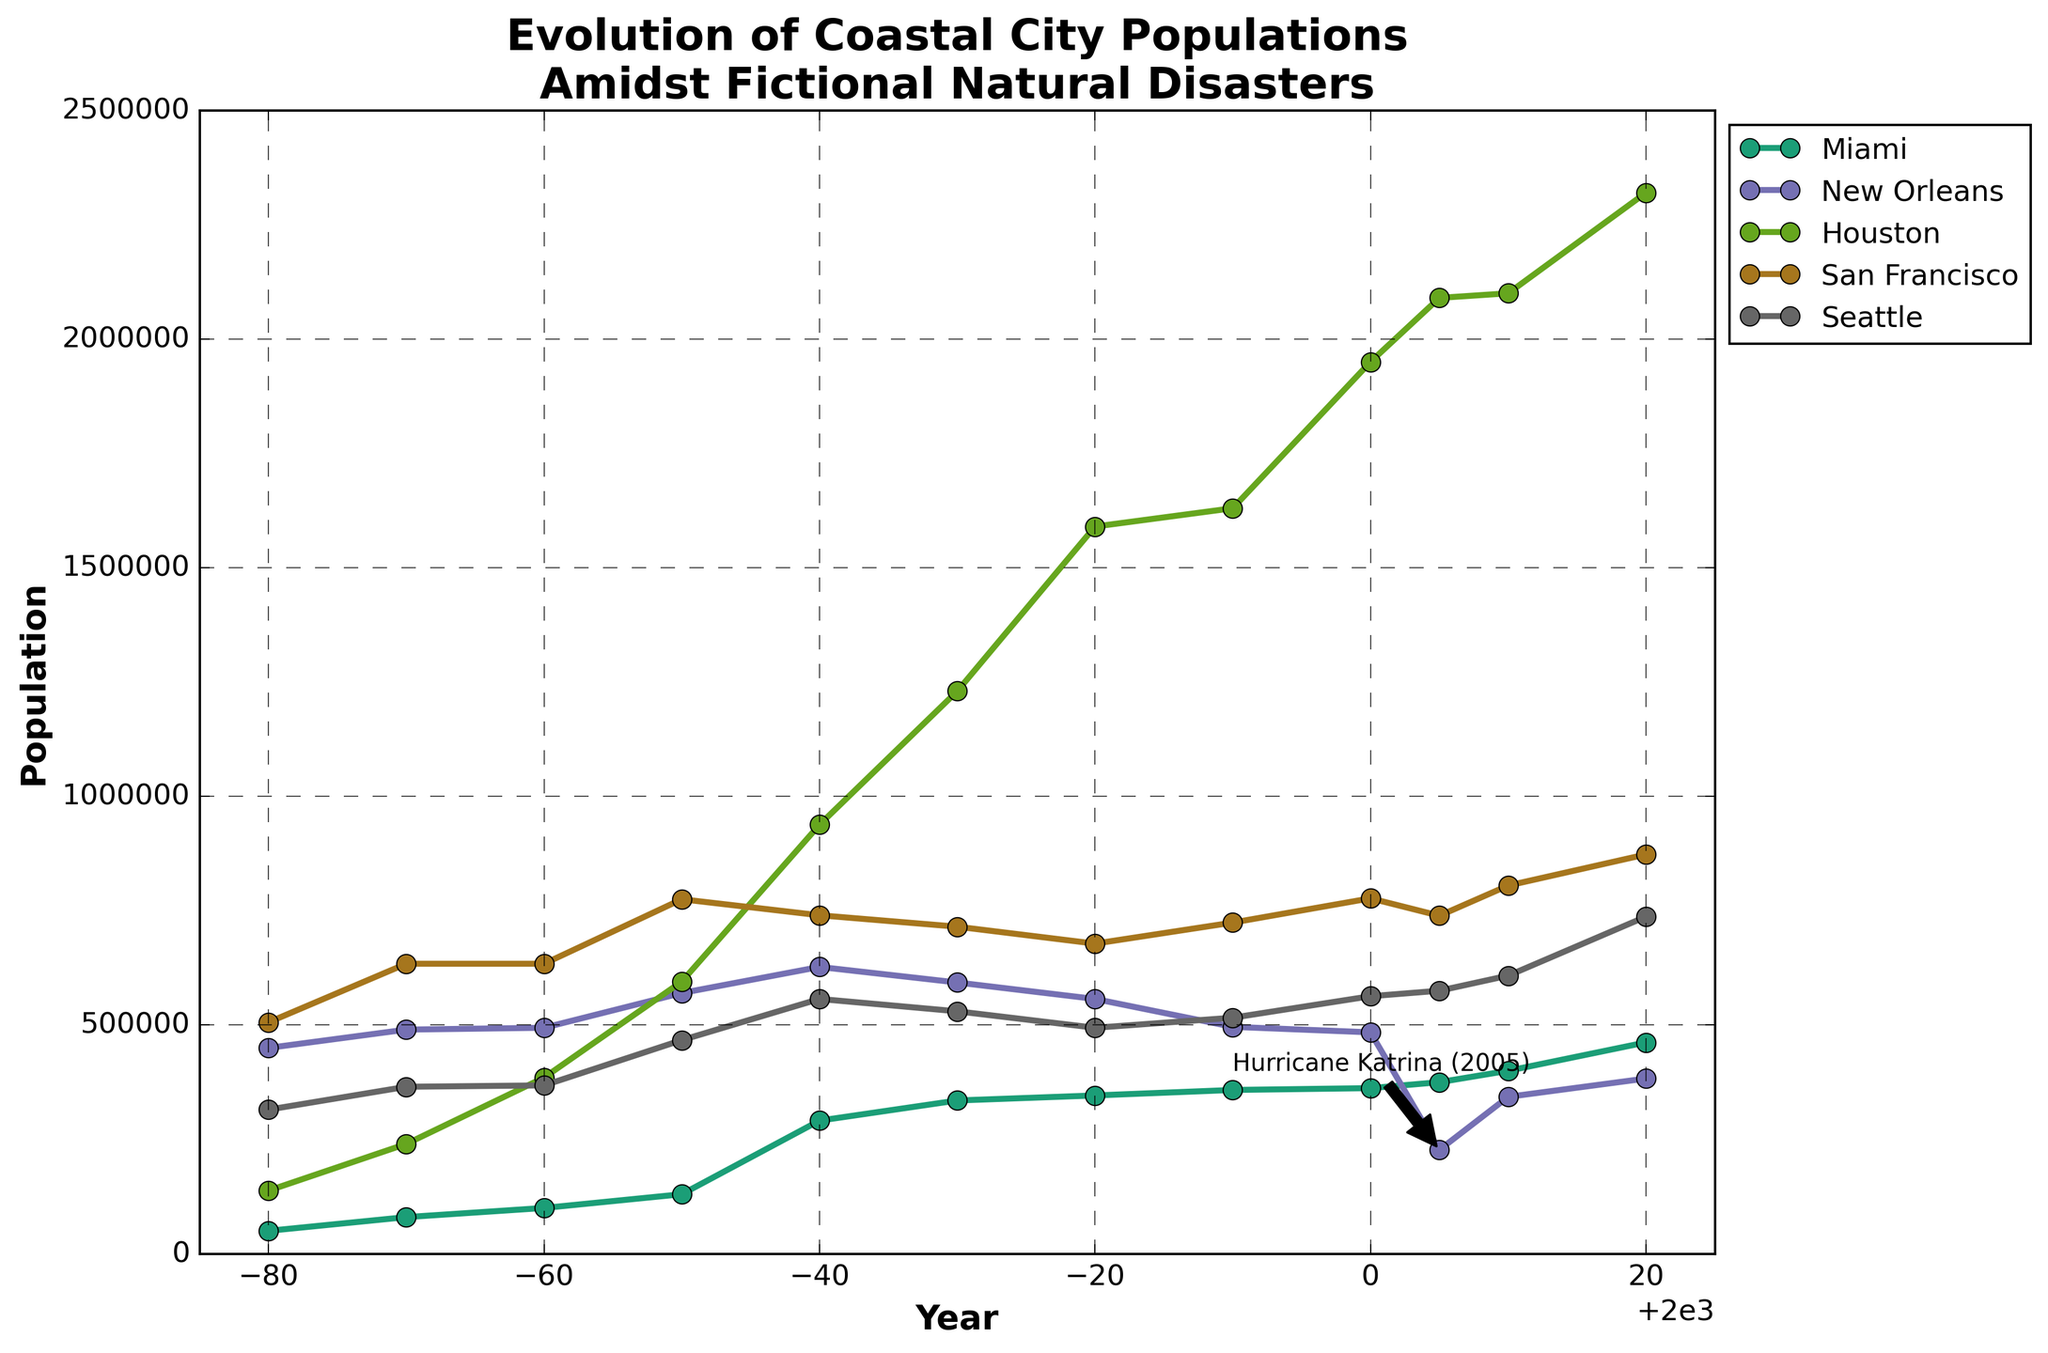What's the title of the figure? The title is typically located at the top of a figure or graph. In this case, it is clearly written above the plot.
Answer: Evolution of Coastal City Populations Amidst Fictional Natural Disasters What are the x-axis and y-axis labels? The x-axis label is usually at the bottom of the graph and the y-axis label is typically at the left side of the plot. Here, they are marked clearly.
Answer: Year, Population What year shows the largest population drop for New Orleans, and what was the population before and after the drop? From the plotted data, the year with the significant population drop is around 2005. Before the drop, the population was around 484,000, and after, it was about 227,000.
Answer: 2005, 484,000, 227,000 Which city had the highest population in 2020? The highest population in 2020 can be identified by looking for the tallest point on the y-axis for that year. Houston's population stands out.
Answer: Houston Between which years did Miami show the most significant population growth, and what were the respective populations? Miami shows the most obvious growth between 1950 and 1960, going from 130,000 to 291,000.
Answer: 1950-1960, 130,000, 291,000 Which city experienced the most dramatic decrease in population after 2000? Referring to the annotations and significant drops in the plot, New Orleans shows the most dramatic decrease due to a fictional disaster around 2005.
Answer: New Orleans Compare the population trends of San Francisco and Seattle between 1940 and 1970. By assessing the plot lines for both cities in the specified period, San Francisco's population first increases and then slightly decreases, while Seattle shows more consistent population growth.
Answer: San Francisco had an initial rise and then a slight decline; Seattle had consistent growth What are the markers used to indicate data points on the plot, and what's their general size? The markers used to denote data points are visible as small circular points on the lines plotted for each city. They are reasonably sized to be clearly visible.
Answer: Circles, size 8 When does Houston's population first surpass 1 million? Checking the plotted line for Houston and observing where it crosses the 1 million mark on the y-axis, it's in the year 1970.
Answer: 1970 